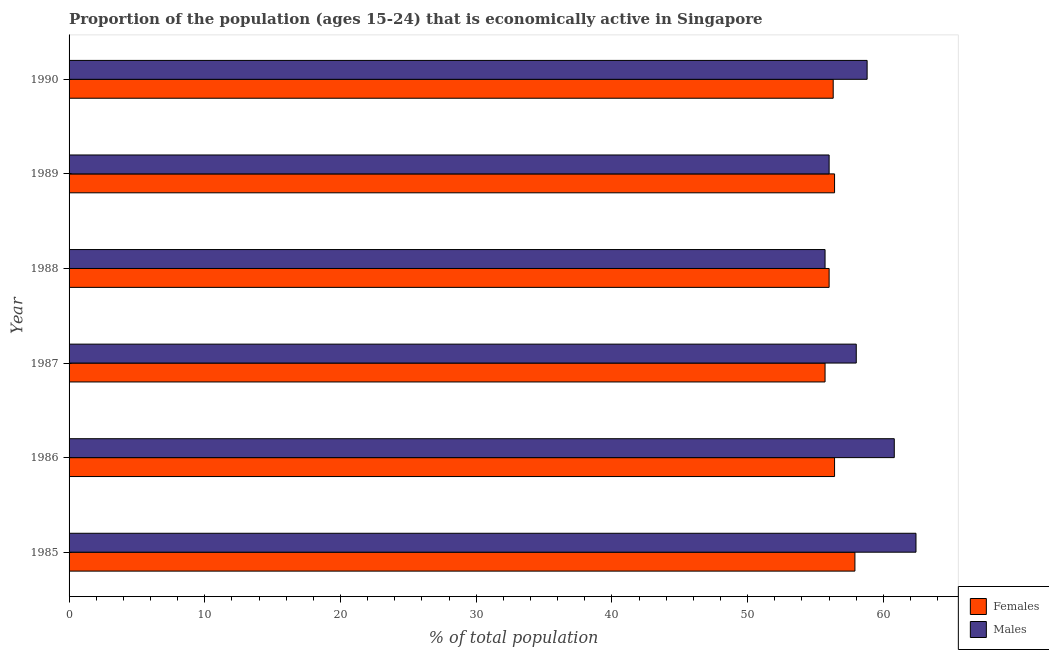How many different coloured bars are there?
Provide a succinct answer. 2. How many groups of bars are there?
Offer a terse response. 6. How many bars are there on the 2nd tick from the top?
Offer a terse response. 2. What is the label of the 2nd group of bars from the top?
Ensure brevity in your answer.  1989. What is the percentage of economically active female population in 1988?
Ensure brevity in your answer.  56. Across all years, what is the maximum percentage of economically active female population?
Offer a terse response. 57.9. Across all years, what is the minimum percentage of economically active female population?
Keep it short and to the point. 55.7. What is the total percentage of economically active female population in the graph?
Keep it short and to the point. 338.7. What is the difference between the percentage of economically active female population in 1986 and that in 1987?
Offer a terse response. 0.7. What is the difference between the percentage of economically active male population in 1985 and the percentage of economically active female population in 1988?
Your response must be concise. 6.4. What is the average percentage of economically active female population per year?
Your answer should be very brief. 56.45. In the year 1986, what is the difference between the percentage of economically active female population and percentage of economically active male population?
Your answer should be compact. -4.4. In how many years, is the percentage of economically active female population greater than 26 %?
Keep it short and to the point. 6. What is the ratio of the percentage of economically active male population in 1986 to that in 1990?
Make the answer very short. 1.03. Is the percentage of economically active female population in 1989 less than that in 1990?
Provide a succinct answer. No. Is the difference between the percentage of economically active female population in 1985 and 1989 greater than the difference between the percentage of economically active male population in 1985 and 1989?
Offer a terse response. No. What is the difference between the highest and the second highest percentage of economically active female population?
Keep it short and to the point. 1.5. What is the difference between the highest and the lowest percentage of economically active male population?
Ensure brevity in your answer.  6.7. In how many years, is the percentage of economically active male population greater than the average percentage of economically active male population taken over all years?
Make the answer very short. 3. What does the 2nd bar from the top in 1987 represents?
Give a very brief answer. Females. What does the 2nd bar from the bottom in 1988 represents?
Give a very brief answer. Males. How many bars are there?
Keep it short and to the point. 12. Are all the bars in the graph horizontal?
Offer a terse response. Yes. How many years are there in the graph?
Ensure brevity in your answer.  6. What is the difference between two consecutive major ticks on the X-axis?
Make the answer very short. 10. Does the graph contain grids?
Offer a terse response. No. How many legend labels are there?
Ensure brevity in your answer.  2. How are the legend labels stacked?
Keep it short and to the point. Vertical. What is the title of the graph?
Ensure brevity in your answer.  Proportion of the population (ages 15-24) that is economically active in Singapore. What is the label or title of the X-axis?
Offer a terse response. % of total population. What is the % of total population in Females in 1985?
Your response must be concise. 57.9. What is the % of total population in Males in 1985?
Make the answer very short. 62.4. What is the % of total population in Females in 1986?
Keep it short and to the point. 56.4. What is the % of total population of Males in 1986?
Keep it short and to the point. 60.8. What is the % of total population of Females in 1987?
Keep it short and to the point. 55.7. What is the % of total population of Males in 1987?
Give a very brief answer. 58. What is the % of total population of Males in 1988?
Provide a succinct answer. 55.7. What is the % of total population in Females in 1989?
Give a very brief answer. 56.4. What is the % of total population in Females in 1990?
Offer a very short reply. 56.3. What is the % of total population of Males in 1990?
Offer a very short reply. 58.8. Across all years, what is the maximum % of total population of Females?
Your answer should be very brief. 57.9. Across all years, what is the maximum % of total population of Males?
Make the answer very short. 62.4. Across all years, what is the minimum % of total population in Females?
Provide a short and direct response. 55.7. Across all years, what is the minimum % of total population of Males?
Your response must be concise. 55.7. What is the total % of total population in Females in the graph?
Offer a terse response. 338.7. What is the total % of total population in Males in the graph?
Offer a terse response. 351.7. What is the difference between the % of total population in Females in 1985 and that in 1987?
Provide a short and direct response. 2.2. What is the difference between the % of total population of Males in 1985 and that in 1987?
Make the answer very short. 4.4. What is the difference between the % of total population of Males in 1985 and that in 1988?
Keep it short and to the point. 6.7. What is the difference between the % of total population of Males in 1985 and that in 1989?
Your answer should be compact. 6.4. What is the difference between the % of total population of Males in 1985 and that in 1990?
Provide a short and direct response. 3.6. What is the difference between the % of total population of Females in 1986 and that in 1988?
Provide a succinct answer. 0.4. What is the difference between the % of total population in Males in 1986 and that in 1988?
Give a very brief answer. 5.1. What is the difference between the % of total population in Males in 1986 and that in 1989?
Keep it short and to the point. 4.8. What is the difference between the % of total population in Males in 1986 and that in 1990?
Your answer should be compact. 2. What is the difference between the % of total population in Females in 1987 and that in 1988?
Provide a short and direct response. -0.3. What is the difference between the % of total population of Males in 1987 and that in 1988?
Your response must be concise. 2.3. What is the difference between the % of total population in Males in 1987 and that in 1989?
Offer a terse response. 2. What is the difference between the % of total population of Males in 1987 and that in 1990?
Your response must be concise. -0.8. What is the difference between the % of total population of Males in 1988 and that in 1989?
Offer a very short reply. -0.3. What is the difference between the % of total population of Females in 1988 and that in 1990?
Ensure brevity in your answer.  -0.3. What is the difference between the % of total population of Females in 1989 and that in 1990?
Offer a very short reply. 0.1. What is the difference between the % of total population of Females in 1985 and the % of total population of Males in 1987?
Make the answer very short. -0.1. What is the difference between the % of total population in Females in 1986 and the % of total population in Males in 1987?
Your answer should be compact. -1.6. What is the difference between the % of total population of Females in 1986 and the % of total population of Males in 1988?
Ensure brevity in your answer.  0.7. What is the difference between the % of total population in Females in 1987 and the % of total population in Males in 1988?
Make the answer very short. 0. What is the difference between the % of total population in Females in 1988 and the % of total population in Males in 1989?
Offer a terse response. 0. What is the difference between the % of total population of Females in 1988 and the % of total population of Males in 1990?
Offer a very short reply. -2.8. What is the difference between the % of total population of Females in 1989 and the % of total population of Males in 1990?
Offer a terse response. -2.4. What is the average % of total population in Females per year?
Make the answer very short. 56.45. What is the average % of total population in Males per year?
Provide a short and direct response. 58.62. In the year 1986, what is the difference between the % of total population in Females and % of total population in Males?
Provide a succinct answer. -4.4. In the year 1987, what is the difference between the % of total population in Females and % of total population in Males?
Your response must be concise. -2.3. In the year 1988, what is the difference between the % of total population in Females and % of total population in Males?
Ensure brevity in your answer.  0.3. In the year 1989, what is the difference between the % of total population in Females and % of total population in Males?
Keep it short and to the point. 0.4. In the year 1990, what is the difference between the % of total population in Females and % of total population in Males?
Ensure brevity in your answer.  -2.5. What is the ratio of the % of total population of Females in 1985 to that in 1986?
Your answer should be very brief. 1.03. What is the ratio of the % of total population in Males in 1985 to that in 1986?
Your answer should be compact. 1.03. What is the ratio of the % of total population of Females in 1985 to that in 1987?
Your response must be concise. 1.04. What is the ratio of the % of total population in Males in 1985 to that in 1987?
Your response must be concise. 1.08. What is the ratio of the % of total population in Females in 1985 to that in 1988?
Offer a very short reply. 1.03. What is the ratio of the % of total population of Males in 1985 to that in 1988?
Your answer should be very brief. 1.12. What is the ratio of the % of total population in Females in 1985 to that in 1989?
Keep it short and to the point. 1.03. What is the ratio of the % of total population in Males in 1985 to that in 1989?
Ensure brevity in your answer.  1.11. What is the ratio of the % of total population of Females in 1985 to that in 1990?
Ensure brevity in your answer.  1.03. What is the ratio of the % of total population of Males in 1985 to that in 1990?
Provide a short and direct response. 1.06. What is the ratio of the % of total population of Females in 1986 to that in 1987?
Provide a short and direct response. 1.01. What is the ratio of the % of total population of Males in 1986 to that in 1987?
Keep it short and to the point. 1.05. What is the ratio of the % of total population of Females in 1986 to that in 1988?
Give a very brief answer. 1.01. What is the ratio of the % of total population in Males in 1986 to that in 1988?
Provide a succinct answer. 1.09. What is the ratio of the % of total population in Females in 1986 to that in 1989?
Offer a terse response. 1. What is the ratio of the % of total population of Males in 1986 to that in 1989?
Your response must be concise. 1.09. What is the ratio of the % of total population in Males in 1986 to that in 1990?
Your response must be concise. 1.03. What is the ratio of the % of total population in Females in 1987 to that in 1988?
Offer a terse response. 0.99. What is the ratio of the % of total population of Males in 1987 to that in 1988?
Keep it short and to the point. 1.04. What is the ratio of the % of total population in Females in 1987 to that in 1989?
Offer a very short reply. 0.99. What is the ratio of the % of total population in Males in 1987 to that in 1989?
Give a very brief answer. 1.04. What is the ratio of the % of total population of Females in 1987 to that in 1990?
Give a very brief answer. 0.99. What is the ratio of the % of total population of Males in 1987 to that in 1990?
Provide a succinct answer. 0.99. What is the ratio of the % of total population in Females in 1988 to that in 1989?
Make the answer very short. 0.99. What is the ratio of the % of total population of Females in 1988 to that in 1990?
Offer a terse response. 0.99. What is the ratio of the % of total population in Males in 1988 to that in 1990?
Your answer should be compact. 0.95. What is the ratio of the % of total population in Females in 1989 to that in 1990?
Your response must be concise. 1. What is the ratio of the % of total population of Males in 1989 to that in 1990?
Keep it short and to the point. 0.95. What is the difference between the highest and the second highest % of total population in Females?
Provide a succinct answer. 1.5. What is the difference between the highest and the lowest % of total population in Males?
Ensure brevity in your answer.  6.7. 